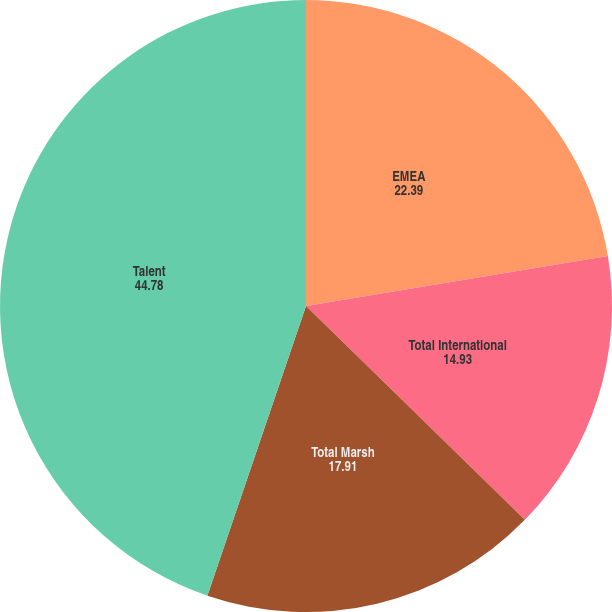<chart> <loc_0><loc_0><loc_500><loc_500><pie_chart><fcel>EMEA<fcel>Total International<fcel>Total Marsh<fcel>Talent<nl><fcel>22.39%<fcel>14.93%<fcel>17.91%<fcel>44.78%<nl></chart> 